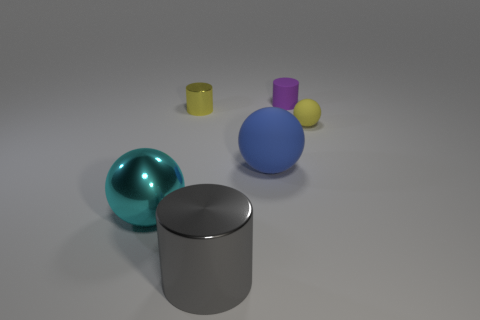Subtract all matte spheres. How many spheres are left? 1 Add 3 yellow metal objects. How many objects exist? 9 Subtract all yellow cylinders. How many cylinders are left? 2 Subtract 3 cylinders. How many cylinders are left? 0 Subtract all red cylinders. Subtract all gray balls. How many cylinders are left? 3 Subtract all blue cylinders. How many cyan balls are left? 1 Subtract all tiny purple matte things. Subtract all yellow balls. How many objects are left? 4 Add 2 blue rubber spheres. How many blue rubber spheres are left? 3 Add 6 tiny purple rubber cylinders. How many tiny purple rubber cylinders exist? 7 Subtract 1 gray cylinders. How many objects are left? 5 